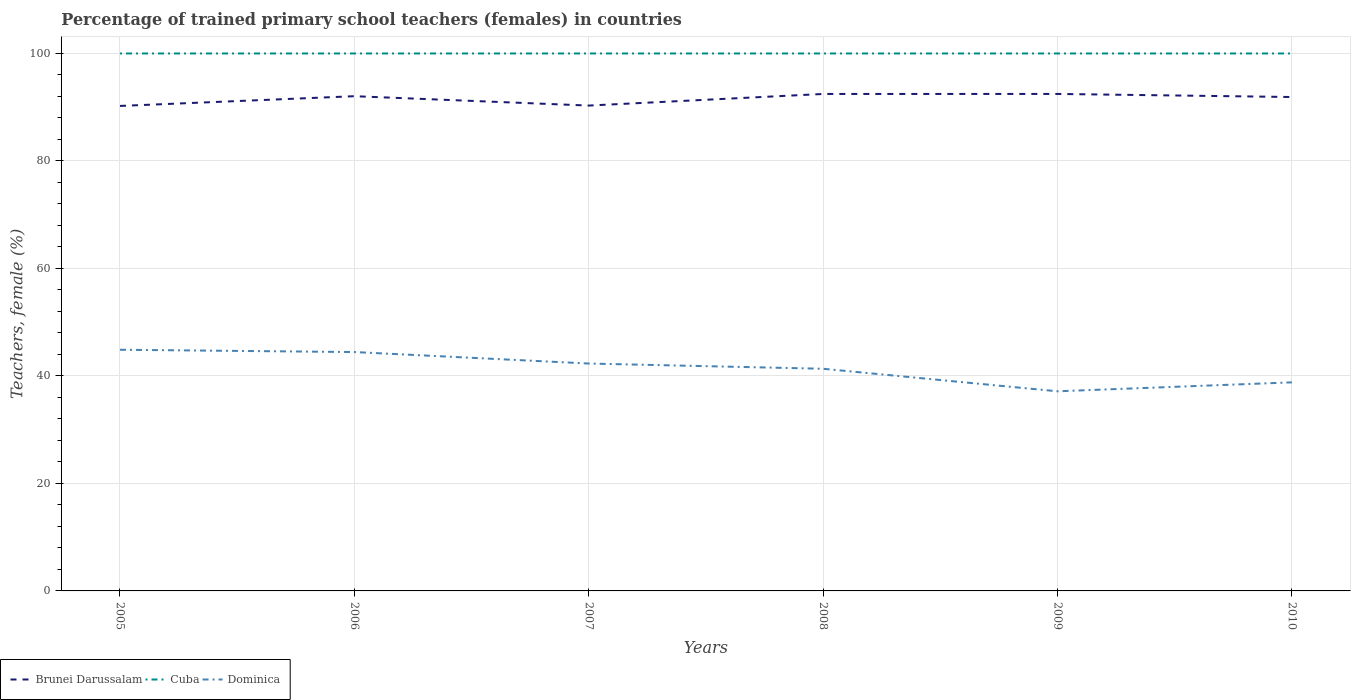Does the line corresponding to Brunei Darussalam intersect with the line corresponding to Dominica?
Make the answer very short. No. Across all years, what is the maximum percentage of trained primary school teachers (females) in Dominica?
Offer a terse response. 37.14. In which year was the percentage of trained primary school teachers (females) in Brunei Darussalam maximum?
Your answer should be very brief. 2005. What is the difference between the highest and the second highest percentage of trained primary school teachers (females) in Dominica?
Keep it short and to the point. 7.73. What is the difference between the highest and the lowest percentage of trained primary school teachers (females) in Brunei Darussalam?
Offer a very short reply. 4. Is the percentage of trained primary school teachers (females) in Cuba strictly greater than the percentage of trained primary school teachers (females) in Brunei Darussalam over the years?
Offer a terse response. No. How many lines are there?
Your answer should be very brief. 3. What is the difference between two consecutive major ticks on the Y-axis?
Provide a succinct answer. 20. Where does the legend appear in the graph?
Offer a terse response. Bottom left. What is the title of the graph?
Give a very brief answer. Percentage of trained primary school teachers (females) in countries. Does "Tajikistan" appear as one of the legend labels in the graph?
Your answer should be compact. No. What is the label or title of the Y-axis?
Ensure brevity in your answer.  Teachers, female (%). What is the Teachers, female (%) in Brunei Darussalam in 2005?
Offer a terse response. 90.24. What is the Teachers, female (%) in Cuba in 2005?
Offer a terse response. 100. What is the Teachers, female (%) of Dominica in 2005?
Keep it short and to the point. 44.87. What is the Teachers, female (%) in Brunei Darussalam in 2006?
Provide a succinct answer. 92.05. What is the Teachers, female (%) in Dominica in 2006?
Give a very brief answer. 44.44. What is the Teachers, female (%) of Brunei Darussalam in 2007?
Your answer should be compact. 90.31. What is the Teachers, female (%) of Dominica in 2007?
Your response must be concise. 42.31. What is the Teachers, female (%) in Brunei Darussalam in 2008?
Your answer should be very brief. 92.47. What is the Teachers, female (%) in Cuba in 2008?
Provide a short and direct response. 100. What is the Teachers, female (%) of Dominica in 2008?
Your answer should be compact. 41.33. What is the Teachers, female (%) in Brunei Darussalam in 2009?
Keep it short and to the point. 92.47. What is the Teachers, female (%) of Cuba in 2009?
Your answer should be compact. 100. What is the Teachers, female (%) of Dominica in 2009?
Offer a terse response. 37.14. What is the Teachers, female (%) of Brunei Darussalam in 2010?
Offer a terse response. 91.9. What is the Teachers, female (%) of Dominica in 2010?
Your answer should be compact. 38.81. Across all years, what is the maximum Teachers, female (%) of Brunei Darussalam?
Give a very brief answer. 92.47. Across all years, what is the maximum Teachers, female (%) in Cuba?
Your answer should be compact. 100. Across all years, what is the maximum Teachers, female (%) of Dominica?
Make the answer very short. 44.87. Across all years, what is the minimum Teachers, female (%) in Brunei Darussalam?
Keep it short and to the point. 90.24. Across all years, what is the minimum Teachers, female (%) in Cuba?
Provide a short and direct response. 100. Across all years, what is the minimum Teachers, female (%) of Dominica?
Your response must be concise. 37.14. What is the total Teachers, female (%) in Brunei Darussalam in the graph?
Offer a terse response. 549.43. What is the total Teachers, female (%) in Cuba in the graph?
Keep it short and to the point. 600. What is the total Teachers, female (%) of Dominica in the graph?
Your response must be concise. 248.91. What is the difference between the Teachers, female (%) in Brunei Darussalam in 2005 and that in 2006?
Your answer should be very brief. -1.81. What is the difference between the Teachers, female (%) of Cuba in 2005 and that in 2006?
Offer a very short reply. 0. What is the difference between the Teachers, female (%) in Dominica in 2005 and that in 2006?
Your response must be concise. 0.43. What is the difference between the Teachers, female (%) of Brunei Darussalam in 2005 and that in 2007?
Provide a short and direct response. -0.07. What is the difference between the Teachers, female (%) in Dominica in 2005 and that in 2007?
Your response must be concise. 2.56. What is the difference between the Teachers, female (%) in Brunei Darussalam in 2005 and that in 2008?
Your answer should be compact. -2.23. What is the difference between the Teachers, female (%) in Dominica in 2005 and that in 2008?
Make the answer very short. 3.54. What is the difference between the Teachers, female (%) of Brunei Darussalam in 2005 and that in 2009?
Keep it short and to the point. -2.23. What is the difference between the Teachers, female (%) in Cuba in 2005 and that in 2009?
Provide a succinct answer. 0. What is the difference between the Teachers, female (%) of Dominica in 2005 and that in 2009?
Keep it short and to the point. 7.73. What is the difference between the Teachers, female (%) in Brunei Darussalam in 2005 and that in 2010?
Provide a short and direct response. -1.66. What is the difference between the Teachers, female (%) of Cuba in 2005 and that in 2010?
Your response must be concise. 0. What is the difference between the Teachers, female (%) of Dominica in 2005 and that in 2010?
Give a very brief answer. 6.07. What is the difference between the Teachers, female (%) of Brunei Darussalam in 2006 and that in 2007?
Your response must be concise. 1.74. What is the difference between the Teachers, female (%) of Cuba in 2006 and that in 2007?
Offer a terse response. 0. What is the difference between the Teachers, female (%) of Dominica in 2006 and that in 2007?
Your response must be concise. 2.14. What is the difference between the Teachers, female (%) of Brunei Darussalam in 2006 and that in 2008?
Provide a succinct answer. -0.42. What is the difference between the Teachers, female (%) of Cuba in 2006 and that in 2008?
Keep it short and to the point. 0. What is the difference between the Teachers, female (%) in Dominica in 2006 and that in 2008?
Keep it short and to the point. 3.11. What is the difference between the Teachers, female (%) in Brunei Darussalam in 2006 and that in 2009?
Your answer should be compact. -0.42. What is the difference between the Teachers, female (%) of Dominica in 2006 and that in 2009?
Keep it short and to the point. 7.3. What is the difference between the Teachers, female (%) in Brunei Darussalam in 2006 and that in 2010?
Offer a terse response. 0.15. What is the difference between the Teachers, female (%) in Cuba in 2006 and that in 2010?
Make the answer very short. 0. What is the difference between the Teachers, female (%) of Dominica in 2006 and that in 2010?
Keep it short and to the point. 5.64. What is the difference between the Teachers, female (%) in Brunei Darussalam in 2007 and that in 2008?
Make the answer very short. -2.16. What is the difference between the Teachers, female (%) in Cuba in 2007 and that in 2008?
Offer a terse response. 0. What is the difference between the Teachers, female (%) of Dominica in 2007 and that in 2008?
Your answer should be compact. 0.97. What is the difference between the Teachers, female (%) of Brunei Darussalam in 2007 and that in 2009?
Offer a very short reply. -2.16. What is the difference between the Teachers, female (%) of Cuba in 2007 and that in 2009?
Your answer should be compact. 0. What is the difference between the Teachers, female (%) in Dominica in 2007 and that in 2009?
Offer a very short reply. 5.16. What is the difference between the Teachers, female (%) in Brunei Darussalam in 2007 and that in 2010?
Provide a succinct answer. -1.59. What is the difference between the Teachers, female (%) of Dominica in 2007 and that in 2010?
Provide a succinct answer. 3.5. What is the difference between the Teachers, female (%) in Brunei Darussalam in 2008 and that in 2009?
Your response must be concise. -0. What is the difference between the Teachers, female (%) in Cuba in 2008 and that in 2009?
Offer a terse response. 0. What is the difference between the Teachers, female (%) in Dominica in 2008 and that in 2009?
Keep it short and to the point. 4.19. What is the difference between the Teachers, female (%) of Brunei Darussalam in 2008 and that in 2010?
Provide a succinct answer. 0.57. What is the difference between the Teachers, female (%) in Cuba in 2008 and that in 2010?
Offer a terse response. 0. What is the difference between the Teachers, female (%) in Dominica in 2008 and that in 2010?
Your answer should be very brief. 2.53. What is the difference between the Teachers, female (%) of Brunei Darussalam in 2009 and that in 2010?
Offer a very short reply. 0.57. What is the difference between the Teachers, female (%) of Cuba in 2009 and that in 2010?
Give a very brief answer. 0. What is the difference between the Teachers, female (%) in Dominica in 2009 and that in 2010?
Your response must be concise. -1.66. What is the difference between the Teachers, female (%) of Brunei Darussalam in 2005 and the Teachers, female (%) of Cuba in 2006?
Provide a short and direct response. -9.76. What is the difference between the Teachers, female (%) of Brunei Darussalam in 2005 and the Teachers, female (%) of Dominica in 2006?
Provide a short and direct response. 45.79. What is the difference between the Teachers, female (%) of Cuba in 2005 and the Teachers, female (%) of Dominica in 2006?
Offer a very short reply. 55.56. What is the difference between the Teachers, female (%) of Brunei Darussalam in 2005 and the Teachers, female (%) of Cuba in 2007?
Provide a short and direct response. -9.76. What is the difference between the Teachers, female (%) in Brunei Darussalam in 2005 and the Teachers, female (%) in Dominica in 2007?
Provide a short and direct response. 47.93. What is the difference between the Teachers, female (%) in Cuba in 2005 and the Teachers, female (%) in Dominica in 2007?
Provide a succinct answer. 57.69. What is the difference between the Teachers, female (%) of Brunei Darussalam in 2005 and the Teachers, female (%) of Cuba in 2008?
Your answer should be very brief. -9.76. What is the difference between the Teachers, female (%) of Brunei Darussalam in 2005 and the Teachers, female (%) of Dominica in 2008?
Your answer should be compact. 48.9. What is the difference between the Teachers, female (%) in Cuba in 2005 and the Teachers, female (%) in Dominica in 2008?
Offer a very short reply. 58.67. What is the difference between the Teachers, female (%) in Brunei Darussalam in 2005 and the Teachers, female (%) in Cuba in 2009?
Provide a short and direct response. -9.76. What is the difference between the Teachers, female (%) of Brunei Darussalam in 2005 and the Teachers, female (%) of Dominica in 2009?
Provide a short and direct response. 53.09. What is the difference between the Teachers, female (%) of Cuba in 2005 and the Teachers, female (%) of Dominica in 2009?
Offer a terse response. 62.86. What is the difference between the Teachers, female (%) of Brunei Darussalam in 2005 and the Teachers, female (%) of Cuba in 2010?
Your answer should be very brief. -9.76. What is the difference between the Teachers, female (%) of Brunei Darussalam in 2005 and the Teachers, female (%) of Dominica in 2010?
Make the answer very short. 51.43. What is the difference between the Teachers, female (%) in Cuba in 2005 and the Teachers, female (%) in Dominica in 2010?
Your answer should be very brief. 61.19. What is the difference between the Teachers, female (%) of Brunei Darussalam in 2006 and the Teachers, female (%) of Cuba in 2007?
Provide a succinct answer. -7.95. What is the difference between the Teachers, female (%) in Brunei Darussalam in 2006 and the Teachers, female (%) in Dominica in 2007?
Give a very brief answer. 49.74. What is the difference between the Teachers, female (%) of Cuba in 2006 and the Teachers, female (%) of Dominica in 2007?
Ensure brevity in your answer.  57.69. What is the difference between the Teachers, female (%) in Brunei Darussalam in 2006 and the Teachers, female (%) in Cuba in 2008?
Provide a succinct answer. -7.95. What is the difference between the Teachers, female (%) in Brunei Darussalam in 2006 and the Teachers, female (%) in Dominica in 2008?
Your response must be concise. 50.72. What is the difference between the Teachers, female (%) in Cuba in 2006 and the Teachers, female (%) in Dominica in 2008?
Offer a very short reply. 58.67. What is the difference between the Teachers, female (%) in Brunei Darussalam in 2006 and the Teachers, female (%) in Cuba in 2009?
Keep it short and to the point. -7.95. What is the difference between the Teachers, female (%) of Brunei Darussalam in 2006 and the Teachers, female (%) of Dominica in 2009?
Your answer should be very brief. 54.91. What is the difference between the Teachers, female (%) in Cuba in 2006 and the Teachers, female (%) in Dominica in 2009?
Make the answer very short. 62.86. What is the difference between the Teachers, female (%) in Brunei Darussalam in 2006 and the Teachers, female (%) in Cuba in 2010?
Provide a short and direct response. -7.95. What is the difference between the Teachers, female (%) in Brunei Darussalam in 2006 and the Teachers, female (%) in Dominica in 2010?
Offer a very short reply. 53.24. What is the difference between the Teachers, female (%) of Cuba in 2006 and the Teachers, female (%) of Dominica in 2010?
Keep it short and to the point. 61.19. What is the difference between the Teachers, female (%) of Brunei Darussalam in 2007 and the Teachers, female (%) of Cuba in 2008?
Provide a short and direct response. -9.69. What is the difference between the Teachers, female (%) in Brunei Darussalam in 2007 and the Teachers, female (%) in Dominica in 2008?
Make the answer very short. 48.97. What is the difference between the Teachers, female (%) in Cuba in 2007 and the Teachers, female (%) in Dominica in 2008?
Your answer should be very brief. 58.67. What is the difference between the Teachers, female (%) in Brunei Darussalam in 2007 and the Teachers, female (%) in Cuba in 2009?
Your answer should be very brief. -9.69. What is the difference between the Teachers, female (%) of Brunei Darussalam in 2007 and the Teachers, female (%) of Dominica in 2009?
Provide a short and direct response. 53.16. What is the difference between the Teachers, female (%) of Cuba in 2007 and the Teachers, female (%) of Dominica in 2009?
Offer a terse response. 62.86. What is the difference between the Teachers, female (%) in Brunei Darussalam in 2007 and the Teachers, female (%) in Cuba in 2010?
Make the answer very short. -9.69. What is the difference between the Teachers, female (%) of Brunei Darussalam in 2007 and the Teachers, female (%) of Dominica in 2010?
Your response must be concise. 51.5. What is the difference between the Teachers, female (%) of Cuba in 2007 and the Teachers, female (%) of Dominica in 2010?
Make the answer very short. 61.19. What is the difference between the Teachers, female (%) in Brunei Darussalam in 2008 and the Teachers, female (%) in Cuba in 2009?
Offer a very short reply. -7.53. What is the difference between the Teachers, female (%) in Brunei Darussalam in 2008 and the Teachers, female (%) in Dominica in 2009?
Give a very brief answer. 55.32. What is the difference between the Teachers, female (%) of Cuba in 2008 and the Teachers, female (%) of Dominica in 2009?
Offer a terse response. 62.86. What is the difference between the Teachers, female (%) in Brunei Darussalam in 2008 and the Teachers, female (%) in Cuba in 2010?
Provide a succinct answer. -7.53. What is the difference between the Teachers, female (%) of Brunei Darussalam in 2008 and the Teachers, female (%) of Dominica in 2010?
Ensure brevity in your answer.  53.66. What is the difference between the Teachers, female (%) of Cuba in 2008 and the Teachers, female (%) of Dominica in 2010?
Your answer should be compact. 61.19. What is the difference between the Teachers, female (%) of Brunei Darussalam in 2009 and the Teachers, female (%) of Cuba in 2010?
Provide a succinct answer. -7.53. What is the difference between the Teachers, female (%) in Brunei Darussalam in 2009 and the Teachers, female (%) in Dominica in 2010?
Ensure brevity in your answer.  53.66. What is the difference between the Teachers, female (%) in Cuba in 2009 and the Teachers, female (%) in Dominica in 2010?
Your answer should be compact. 61.19. What is the average Teachers, female (%) of Brunei Darussalam per year?
Keep it short and to the point. 91.57. What is the average Teachers, female (%) of Cuba per year?
Your response must be concise. 100. What is the average Teachers, female (%) of Dominica per year?
Give a very brief answer. 41.48. In the year 2005, what is the difference between the Teachers, female (%) in Brunei Darussalam and Teachers, female (%) in Cuba?
Your answer should be very brief. -9.76. In the year 2005, what is the difference between the Teachers, female (%) of Brunei Darussalam and Teachers, female (%) of Dominica?
Keep it short and to the point. 45.36. In the year 2005, what is the difference between the Teachers, female (%) in Cuba and Teachers, female (%) in Dominica?
Keep it short and to the point. 55.13. In the year 2006, what is the difference between the Teachers, female (%) of Brunei Darussalam and Teachers, female (%) of Cuba?
Your answer should be compact. -7.95. In the year 2006, what is the difference between the Teachers, female (%) in Brunei Darussalam and Teachers, female (%) in Dominica?
Make the answer very short. 47.6. In the year 2006, what is the difference between the Teachers, female (%) of Cuba and Teachers, female (%) of Dominica?
Provide a succinct answer. 55.56. In the year 2007, what is the difference between the Teachers, female (%) of Brunei Darussalam and Teachers, female (%) of Cuba?
Give a very brief answer. -9.69. In the year 2007, what is the difference between the Teachers, female (%) of Brunei Darussalam and Teachers, female (%) of Dominica?
Offer a terse response. 48. In the year 2007, what is the difference between the Teachers, female (%) in Cuba and Teachers, female (%) in Dominica?
Your answer should be very brief. 57.69. In the year 2008, what is the difference between the Teachers, female (%) in Brunei Darussalam and Teachers, female (%) in Cuba?
Make the answer very short. -7.53. In the year 2008, what is the difference between the Teachers, female (%) of Brunei Darussalam and Teachers, female (%) of Dominica?
Provide a succinct answer. 51.13. In the year 2008, what is the difference between the Teachers, female (%) in Cuba and Teachers, female (%) in Dominica?
Your answer should be compact. 58.67. In the year 2009, what is the difference between the Teachers, female (%) of Brunei Darussalam and Teachers, female (%) of Cuba?
Make the answer very short. -7.53. In the year 2009, what is the difference between the Teachers, female (%) in Brunei Darussalam and Teachers, female (%) in Dominica?
Make the answer very short. 55.33. In the year 2009, what is the difference between the Teachers, female (%) of Cuba and Teachers, female (%) of Dominica?
Your response must be concise. 62.86. In the year 2010, what is the difference between the Teachers, female (%) in Brunei Darussalam and Teachers, female (%) in Cuba?
Ensure brevity in your answer.  -8.1. In the year 2010, what is the difference between the Teachers, female (%) of Brunei Darussalam and Teachers, female (%) of Dominica?
Your answer should be very brief. 53.09. In the year 2010, what is the difference between the Teachers, female (%) in Cuba and Teachers, female (%) in Dominica?
Give a very brief answer. 61.19. What is the ratio of the Teachers, female (%) in Brunei Darussalam in 2005 to that in 2006?
Your response must be concise. 0.98. What is the ratio of the Teachers, female (%) of Cuba in 2005 to that in 2006?
Provide a succinct answer. 1. What is the ratio of the Teachers, female (%) in Dominica in 2005 to that in 2006?
Give a very brief answer. 1.01. What is the ratio of the Teachers, female (%) in Cuba in 2005 to that in 2007?
Offer a terse response. 1. What is the ratio of the Teachers, female (%) in Dominica in 2005 to that in 2007?
Your answer should be compact. 1.06. What is the ratio of the Teachers, female (%) of Brunei Darussalam in 2005 to that in 2008?
Your answer should be very brief. 0.98. What is the ratio of the Teachers, female (%) in Dominica in 2005 to that in 2008?
Your response must be concise. 1.09. What is the ratio of the Teachers, female (%) of Brunei Darussalam in 2005 to that in 2009?
Give a very brief answer. 0.98. What is the ratio of the Teachers, female (%) of Dominica in 2005 to that in 2009?
Your response must be concise. 1.21. What is the ratio of the Teachers, female (%) in Brunei Darussalam in 2005 to that in 2010?
Provide a short and direct response. 0.98. What is the ratio of the Teachers, female (%) in Cuba in 2005 to that in 2010?
Keep it short and to the point. 1. What is the ratio of the Teachers, female (%) in Dominica in 2005 to that in 2010?
Make the answer very short. 1.16. What is the ratio of the Teachers, female (%) in Brunei Darussalam in 2006 to that in 2007?
Your answer should be compact. 1.02. What is the ratio of the Teachers, female (%) in Cuba in 2006 to that in 2007?
Ensure brevity in your answer.  1. What is the ratio of the Teachers, female (%) in Dominica in 2006 to that in 2007?
Offer a terse response. 1.05. What is the ratio of the Teachers, female (%) of Brunei Darussalam in 2006 to that in 2008?
Offer a terse response. 1. What is the ratio of the Teachers, female (%) in Dominica in 2006 to that in 2008?
Offer a terse response. 1.08. What is the ratio of the Teachers, female (%) in Cuba in 2006 to that in 2009?
Make the answer very short. 1. What is the ratio of the Teachers, female (%) in Dominica in 2006 to that in 2009?
Your answer should be very brief. 1.2. What is the ratio of the Teachers, female (%) of Cuba in 2006 to that in 2010?
Keep it short and to the point. 1. What is the ratio of the Teachers, female (%) in Dominica in 2006 to that in 2010?
Ensure brevity in your answer.  1.15. What is the ratio of the Teachers, female (%) in Brunei Darussalam in 2007 to that in 2008?
Your answer should be compact. 0.98. What is the ratio of the Teachers, female (%) of Dominica in 2007 to that in 2008?
Make the answer very short. 1.02. What is the ratio of the Teachers, female (%) in Brunei Darussalam in 2007 to that in 2009?
Provide a succinct answer. 0.98. What is the ratio of the Teachers, female (%) of Dominica in 2007 to that in 2009?
Your response must be concise. 1.14. What is the ratio of the Teachers, female (%) of Brunei Darussalam in 2007 to that in 2010?
Provide a succinct answer. 0.98. What is the ratio of the Teachers, female (%) of Cuba in 2007 to that in 2010?
Give a very brief answer. 1. What is the ratio of the Teachers, female (%) in Dominica in 2007 to that in 2010?
Your response must be concise. 1.09. What is the ratio of the Teachers, female (%) of Dominica in 2008 to that in 2009?
Provide a short and direct response. 1.11. What is the ratio of the Teachers, female (%) in Brunei Darussalam in 2008 to that in 2010?
Keep it short and to the point. 1.01. What is the ratio of the Teachers, female (%) in Dominica in 2008 to that in 2010?
Provide a succinct answer. 1.07. What is the ratio of the Teachers, female (%) of Brunei Darussalam in 2009 to that in 2010?
Give a very brief answer. 1.01. What is the ratio of the Teachers, female (%) in Dominica in 2009 to that in 2010?
Your answer should be compact. 0.96. What is the difference between the highest and the second highest Teachers, female (%) of Brunei Darussalam?
Your response must be concise. 0. What is the difference between the highest and the second highest Teachers, female (%) in Cuba?
Make the answer very short. 0. What is the difference between the highest and the second highest Teachers, female (%) in Dominica?
Offer a very short reply. 0.43. What is the difference between the highest and the lowest Teachers, female (%) of Brunei Darussalam?
Keep it short and to the point. 2.23. What is the difference between the highest and the lowest Teachers, female (%) in Cuba?
Keep it short and to the point. 0. What is the difference between the highest and the lowest Teachers, female (%) in Dominica?
Provide a succinct answer. 7.73. 